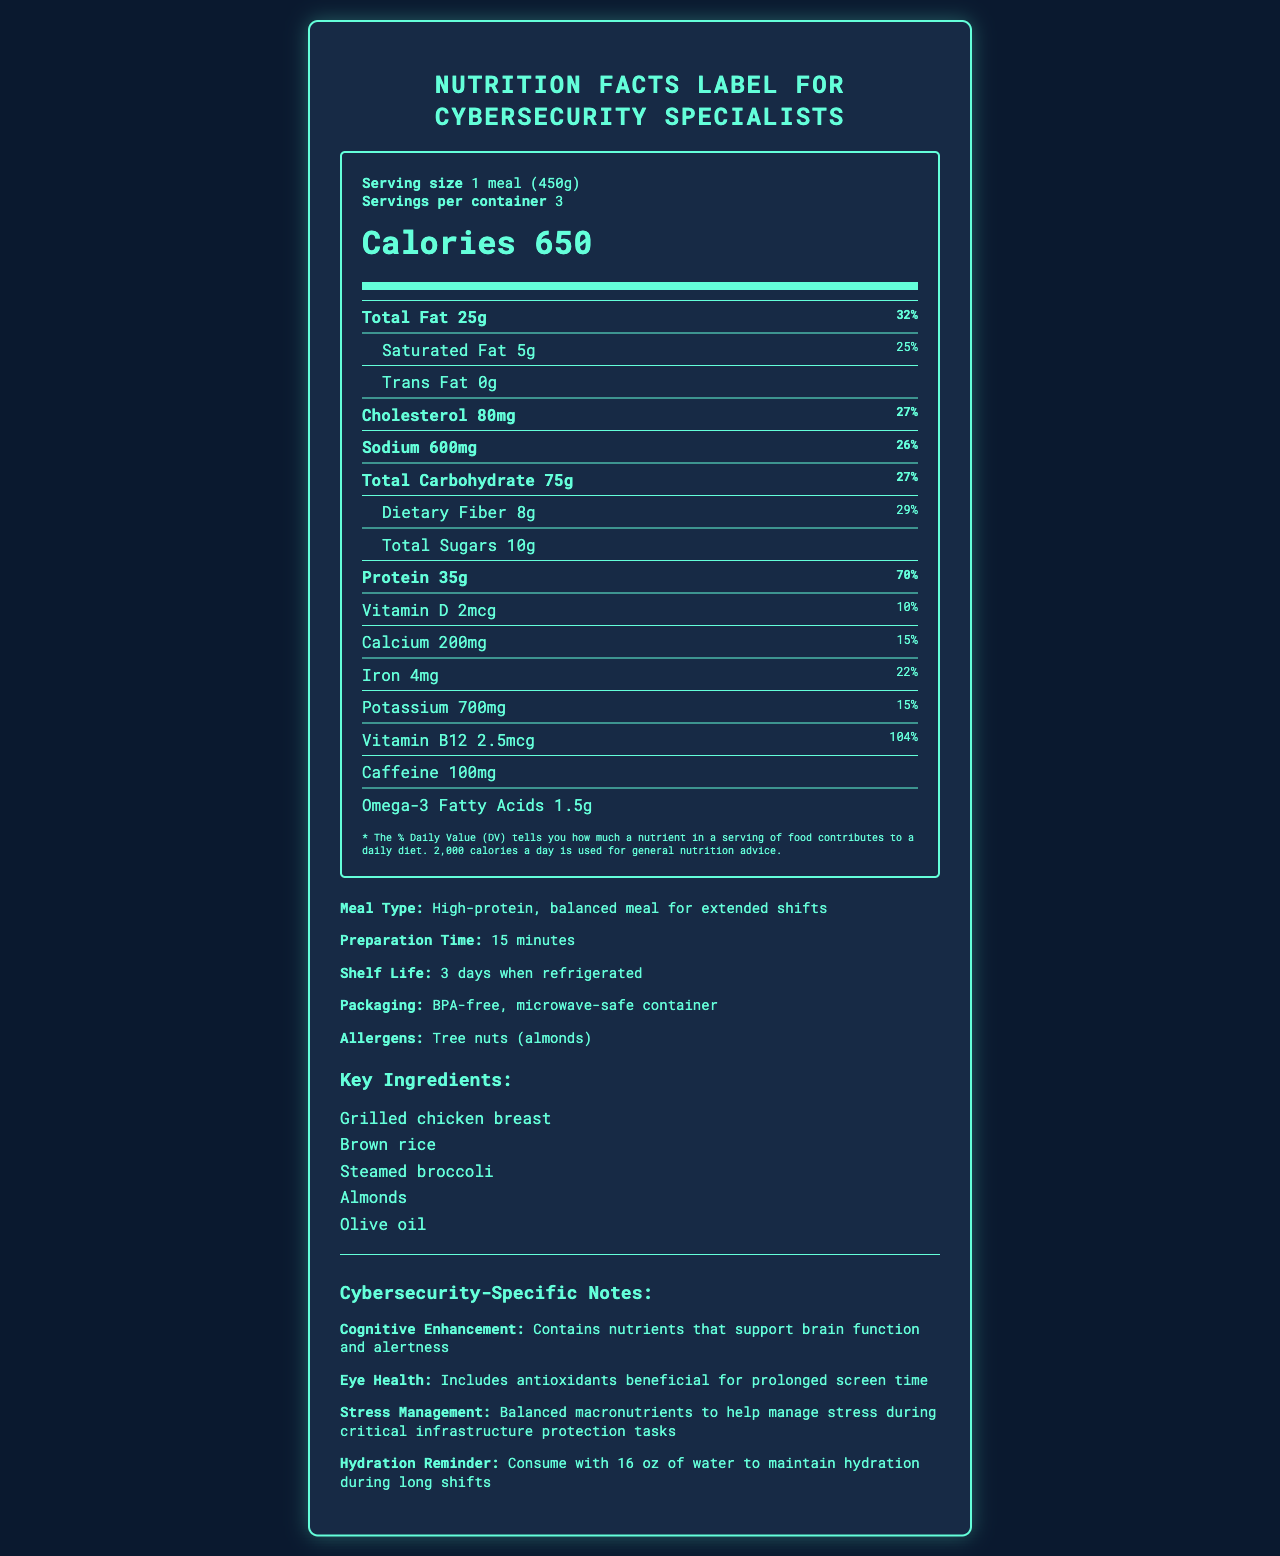what is the serving size? The serving size is listed at the top of the nutrition label under the serving info section.
Answer: 1 meal (450g) how many calories are there per serving? The calories per serving are prominently displayed in the main part of the nutrition label.
Answer: 650 calories how much total fat does one serving contain? The total fat content is listed in the nutrient section of the nutrition label.
Answer: 25g what percentage of the daily value for protein is provided by one serving? The daily value percentage for protein is specified alongside its quantity in grams.
Answer: 70% how much fiber does one serving provide? The dietary fiber content is found under the total carbohydrate section in the nutrition facts.
Answer: 8g how many servings are in the container? The number of servings per container is shown at the top of the nutrition label.
Answer: 3 which of the following nutrients is highest per serving? A. Calcium B. Iron C. Sodium D. Cholesterol Sodium per serving is 600mg, which is higher than calcium (200mg), iron (4mg), and cholesterol (80mg).
Answer: C. Sodium what is the total carbohydrate content per serving? The total carbohydrate content is listed in the nutrient section of the nutrition label.
Answer: 75g does this meal contain any tree nuts? The allergens section specifies that the meal contains tree nuts (almonds).
Answer: Yes what type of container is used for packaging? A. BPA-free, microwave-safe B. Glass container C. Plastic with BPA D. Eco-friendly paper The document states that the packaging is BPA-free and microwave-safe.
Answer: A. BPA-free, microwave-safe what are some key benefits of this meal for cybersecurity specialists? The cybersecurity-specific notes section lists these benefits aimed at cybersecurity specialists.
Answer: Cognitive enhancement, eye health, stress management, hydration reminder how long can this meal be stored when refrigerated? The shelf life is indicated in the additional info section of the document.
Answer: 3 days how many grams of saturated fat are in one serving? The saturated fat content is listed under the total fat in the nutrient section.
Answer: 5g which ingredient is included in the key ingredients list for this meal? A. Beef B. Tofu C. Grilled chicken breast D. Fish The key ingredients list includes grilled chicken breast along with other ingredients.
Answer: C. Grilled chicken breast what is the preparation time for this meal? The preparation time is mentioned in the additional info section.
Answer: 15 minutes describe the main idea of the document. The document is a comprehensive nutrition label tailored for cybersecurity specialists, highlighting macro and micronutrient information, key ingredients, allergens, preparation details, and specific benefits for those working extended shifts. It also notes compliance with government food safety and sourcing regulations.
Answer: The document provides the nutrition facts label for a high-protein, balanced meal designed specifically for cybersecurity specialists working extended shifts. It includes information on serving size, calories, nutrients, key ingredients, allergens, and additional benefits tailored to support cognitive function, eye health, stress management, and hydration. The meal also meets government security compliance standards. how much vitamin B12 is in one serving? The vitamin B12 content is specifically mentioned in the nutrient section of the label.
Answer: 2.5mcg what is the total sugar content in one serving? The total sugars are listed under the carbohydrate section in the nutrition facts.
Answer: 10g how much caffeine is in this meal? The caffeine content is listed at the bottom of the nutrient section.
Answer: 100mg what is the unique feature for traceability compliance? The government security compliance section mentions that each meal is equipped with a unique QR code for traceability.
Answer: Each meal has a unique QR code for full ingredient traceability how much omega-3 fatty acids are in one serving? The omega-3 fatty acids content is noted at the bottom of the nutrient section.
Answer: 1.5g what are the benefits related to stress for cybersecurity specialists mentioned in the document? The stress management benefit is described in the cybersecurity-specific notes section.
Answer: Balanced macronutrients help manage stress during critical infrastructure protection tasks who is the supplier of the ingredients? The document states that all ingredients are sourced from approved suppliers but does not name the specific suppliers.
Answer: Cannot be determined 